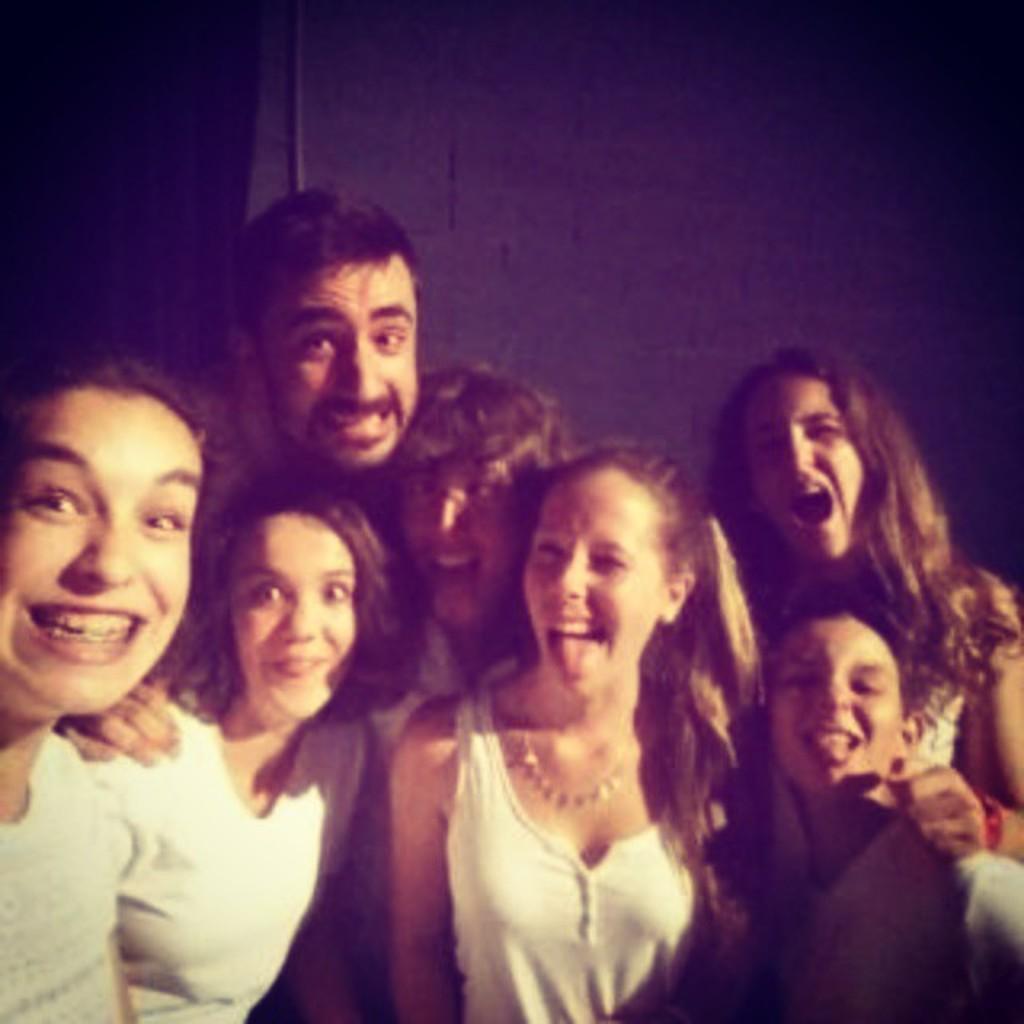Can you describe this image briefly? In the center of the image there are people. In the background of the image there is wall. 